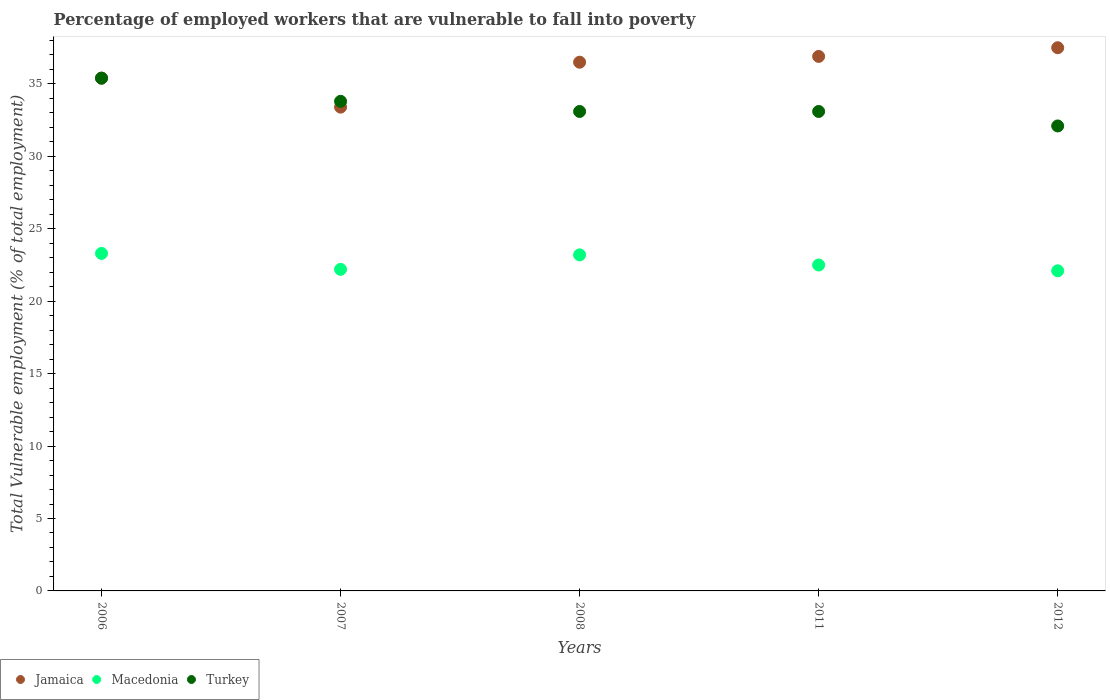What is the percentage of employed workers who are vulnerable to fall into poverty in Turkey in 2006?
Offer a very short reply. 35.4. Across all years, what is the maximum percentage of employed workers who are vulnerable to fall into poverty in Jamaica?
Your answer should be compact. 37.5. Across all years, what is the minimum percentage of employed workers who are vulnerable to fall into poverty in Jamaica?
Offer a very short reply. 33.4. In which year was the percentage of employed workers who are vulnerable to fall into poverty in Turkey maximum?
Make the answer very short. 2006. What is the total percentage of employed workers who are vulnerable to fall into poverty in Macedonia in the graph?
Your response must be concise. 113.3. What is the difference between the percentage of employed workers who are vulnerable to fall into poverty in Jamaica in 2008 and the percentage of employed workers who are vulnerable to fall into poverty in Turkey in 2007?
Provide a short and direct response. 2.7. What is the average percentage of employed workers who are vulnerable to fall into poverty in Macedonia per year?
Your response must be concise. 22.66. In the year 2006, what is the difference between the percentage of employed workers who are vulnerable to fall into poverty in Macedonia and percentage of employed workers who are vulnerable to fall into poverty in Turkey?
Provide a short and direct response. -12.1. In how many years, is the percentage of employed workers who are vulnerable to fall into poverty in Turkey greater than 8 %?
Your answer should be very brief. 5. What is the ratio of the percentage of employed workers who are vulnerable to fall into poverty in Turkey in 2006 to that in 2008?
Offer a very short reply. 1.07. Is the difference between the percentage of employed workers who are vulnerable to fall into poverty in Macedonia in 2006 and 2007 greater than the difference between the percentage of employed workers who are vulnerable to fall into poverty in Turkey in 2006 and 2007?
Provide a short and direct response. No. What is the difference between the highest and the second highest percentage of employed workers who are vulnerable to fall into poverty in Jamaica?
Ensure brevity in your answer.  0.6. What is the difference between the highest and the lowest percentage of employed workers who are vulnerable to fall into poverty in Macedonia?
Provide a succinct answer. 1.2. Is the sum of the percentage of employed workers who are vulnerable to fall into poverty in Turkey in 2008 and 2011 greater than the maximum percentage of employed workers who are vulnerable to fall into poverty in Jamaica across all years?
Your answer should be compact. Yes. Is it the case that in every year, the sum of the percentage of employed workers who are vulnerable to fall into poverty in Turkey and percentage of employed workers who are vulnerable to fall into poverty in Macedonia  is greater than the percentage of employed workers who are vulnerable to fall into poverty in Jamaica?
Your answer should be compact. Yes. How many dotlines are there?
Offer a terse response. 3. Are the values on the major ticks of Y-axis written in scientific E-notation?
Provide a succinct answer. No. Where does the legend appear in the graph?
Make the answer very short. Bottom left. How many legend labels are there?
Offer a very short reply. 3. How are the legend labels stacked?
Keep it short and to the point. Horizontal. What is the title of the graph?
Ensure brevity in your answer.  Percentage of employed workers that are vulnerable to fall into poverty. Does "Chile" appear as one of the legend labels in the graph?
Give a very brief answer. No. What is the label or title of the Y-axis?
Offer a very short reply. Total Vulnerable employment (% of total employment). What is the Total Vulnerable employment (% of total employment) in Jamaica in 2006?
Your response must be concise. 35.4. What is the Total Vulnerable employment (% of total employment) in Macedonia in 2006?
Keep it short and to the point. 23.3. What is the Total Vulnerable employment (% of total employment) of Turkey in 2006?
Your response must be concise. 35.4. What is the Total Vulnerable employment (% of total employment) in Jamaica in 2007?
Give a very brief answer. 33.4. What is the Total Vulnerable employment (% of total employment) of Macedonia in 2007?
Your answer should be very brief. 22.2. What is the Total Vulnerable employment (% of total employment) of Turkey in 2007?
Offer a terse response. 33.8. What is the Total Vulnerable employment (% of total employment) in Jamaica in 2008?
Your answer should be very brief. 36.5. What is the Total Vulnerable employment (% of total employment) of Macedonia in 2008?
Offer a very short reply. 23.2. What is the Total Vulnerable employment (% of total employment) of Turkey in 2008?
Your answer should be compact. 33.1. What is the Total Vulnerable employment (% of total employment) in Jamaica in 2011?
Offer a very short reply. 36.9. What is the Total Vulnerable employment (% of total employment) of Macedonia in 2011?
Provide a succinct answer. 22.5. What is the Total Vulnerable employment (% of total employment) of Turkey in 2011?
Keep it short and to the point. 33.1. What is the Total Vulnerable employment (% of total employment) of Jamaica in 2012?
Make the answer very short. 37.5. What is the Total Vulnerable employment (% of total employment) in Macedonia in 2012?
Give a very brief answer. 22.1. What is the Total Vulnerable employment (% of total employment) in Turkey in 2012?
Provide a succinct answer. 32.1. Across all years, what is the maximum Total Vulnerable employment (% of total employment) in Jamaica?
Provide a short and direct response. 37.5. Across all years, what is the maximum Total Vulnerable employment (% of total employment) of Macedonia?
Your answer should be very brief. 23.3. Across all years, what is the maximum Total Vulnerable employment (% of total employment) in Turkey?
Offer a very short reply. 35.4. Across all years, what is the minimum Total Vulnerable employment (% of total employment) of Jamaica?
Offer a terse response. 33.4. Across all years, what is the minimum Total Vulnerable employment (% of total employment) of Macedonia?
Ensure brevity in your answer.  22.1. Across all years, what is the minimum Total Vulnerable employment (% of total employment) in Turkey?
Your response must be concise. 32.1. What is the total Total Vulnerable employment (% of total employment) of Jamaica in the graph?
Provide a short and direct response. 179.7. What is the total Total Vulnerable employment (% of total employment) in Macedonia in the graph?
Provide a short and direct response. 113.3. What is the total Total Vulnerable employment (% of total employment) in Turkey in the graph?
Provide a succinct answer. 167.5. What is the difference between the Total Vulnerable employment (% of total employment) of Turkey in 2006 and that in 2007?
Your answer should be compact. 1.6. What is the difference between the Total Vulnerable employment (% of total employment) in Turkey in 2006 and that in 2008?
Offer a terse response. 2.3. What is the difference between the Total Vulnerable employment (% of total employment) of Macedonia in 2006 and that in 2011?
Keep it short and to the point. 0.8. What is the difference between the Total Vulnerable employment (% of total employment) of Macedonia in 2006 and that in 2012?
Give a very brief answer. 1.2. What is the difference between the Total Vulnerable employment (% of total employment) of Turkey in 2006 and that in 2012?
Provide a short and direct response. 3.3. What is the difference between the Total Vulnerable employment (% of total employment) in Macedonia in 2007 and that in 2008?
Make the answer very short. -1. What is the difference between the Total Vulnerable employment (% of total employment) in Turkey in 2007 and that in 2008?
Your answer should be very brief. 0.7. What is the difference between the Total Vulnerable employment (% of total employment) in Macedonia in 2007 and that in 2011?
Your answer should be very brief. -0.3. What is the difference between the Total Vulnerable employment (% of total employment) of Turkey in 2007 and that in 2012?
Provide a succinct answer. 1.7. What is the difference between the Total Vulnerable employment (% of total employment) in Macedonia in 2008 and that in 2011?
Your answer should be very brief. 0.7. What is the difference between the Total Vulnerable employment (% of total employment) in Turkey in 2008 and that in 2011?
Offer a very short reply. 0. What is the difference between the Total Vulnerable employment (% of total employment) of Macedonia in 2008 and that in 2012?
Your response must be concise. 1.1. What is the difference between the Total Vulnerable employment (% of total employment) of Jamaica in 2006 and the Total Vulnerable employment (% of total employment) of Turkey in 2008?
Provide a succinct answer. 2.3. What is the difference between the Total Vulnerable employment (% of total employment) in Macedonia in 2006 and the Total Vulnerable employment (% of total employment) in Turkey in 2008?
Provide a succinct answer. -9.8. What is the difference between the Total Vulnerable employment (% of total employment) in Jamaica in 2006 and the Total Vulnerable employment (% of total employment) in Macedonia in 2011?
Ensure brevity in your answer.  12.9. What is the difference between the Total Vulnerable employment (% of total employment) of Jamaica in 2006 and the Total Vulnerable employment (% of total employment) of Turkey in 2012?
Provide a short and direct response. 3.3. What is the difference between the Total Vulnerable employment (% of total employment) of Macedonia in 2006 and the Total Vulnerable employment (% of total employment) of Turkey in 2012?
Offer a very short reply. -8.8. What is the difference between the Total Vulnerable employment (% of total employment) of Jamaica in 2007 and the Total Vulnerable employment (% of total employment) of Turkey in 2008?
Offer a terse response. 0.3. What is the difference between the Total Vulnerable employment (% of total employment) of Jamaica in 2007 and the Total Vulnerable employment (% of total employment) of Turkey in 2011?
Provide a succinct answer. 0.3. What is the difference between the Total Vulnerable employment (% of total employment) in Macedonia in 2007 and the Total Vulnerable employment (% of total employment) in Turkey in 2011?
Your answer should be very brief. -10.9. What is the difference between the Total Vulnerable employment (% of total employment) in Jamaica in 2007 and the Total Vulnerable employment (% of total employment) in Macedonia in 2012?
Provide a short and direct response. 11.3. What is the difference between the Total Vulnerable employment (% of total employment) in Jamaica in 2007 and the Total Vulnerable employment (% of total employment) in Turkey in 2012?
Offer a terse response. 1.3. What is the difference between the Total Vulnerable employment (% of total employment) of Jamaica in 2008 and the Total Vulnerable employment (% of total employment) of Macedonia in 2011?
Make the answer very short. 14. What is the difference between the Total Vulnerable employment (% of total employment) of Jamaica in 2008 and the Total Vulnerable employment (% of total employment) of Macedonia in 2012?
Provide a succinct answer. 14.4. What is the difference between the Total Vulnerable employment (% of total employment) of Jamaica in 2011 and the Total Vulnerable employment (% of total employment) of Macedonia in 2012?
Your answer should be very brief. 14.8. What is the difference between the Total Vulnerable employment (% of total employment) of Macedonia in 2011 and the Total Vulnerable employment (% of total employment) of Turkey in 2012?
Your response must be concise. -9.6. What is the average Total Vulnerable employment (% of total employment) in Jamaica per year?
Provide a succinct answer. 35.94. What is the average Total Vulnerable employment (% of total employment) in Macedonia per year?
Provide a succinct answer. 22.66. What is the average Total Vulnerable employment (% of total employment) of Turkey per year?
Offer a terse response. 33.5. In the year 2007, what is the difference between the Total Vulnerable employment (% of total employment) of Jamaica and Total Vulnerable employment (% of total employment) of Macedonia?
Your answer should be compact. 11.2. In the year 2007, what is the difference between the Total Vulnerable employment (% of total employment) in Jamaica and Total Vulnerable employment (% of total employment) in Turkey?
Your answer should be compact. -0.4. In the year 2008, what is the difference between the Total Vulnerable employment (% of total employment) of Jamaica and Total Vulnerable employment (% of total employment) of Macedonia?
Ensure brevity in your answer.  13.3. In the year 2008, what is the difference between the Total Vulnerable employment (% of total employment) in Jamaica and Total Vulnerable employment (% of total employment) in Turkey?
Your answer should be very brief. 3.4. In the year 2011, what is the difference between the Total Vulnerable employment (% of total employment) in Jamaica and Total Vulnerable employment (% of total employment) in Turkey?
Ensure brevity in your answer.  3.8. In the year 2011, what is the difference between the Total Vulnerable employment (% of total employment) of Macedonia and Total Vulnerable employment (% of total employment) of Turkey?
Your answer should be compact. -10.6. In the year 2012, what is the difference between the Total Vulnerable employment (% of total employment) of Jamaica and Total Vulnerable employment (% of total employment) of Macedonia?
Ensure brevity in your answer.  15.4. In the year 2012, what is the difference between the Total Vulnerable employment (% of total employment) of Jamaica and Total Vulnerable employment (% of total employment) of Turkey?
Make the answer very short. 5.4. In the year 2012, what is the difference between the Total Vulnerable employment (% of total employment) in Macedonia and Total Vulnerable employment (% of total employment) in Turkey?
Give a very brief answer. -10. What is the ratio of the Total Vulnerable employment (% of total employment) in Jamaica in 2006 to that in 2007?
Offer a terse response. 1.06. What is the ratio of the Total Vulnerable employment (% of total employment) in Macedonia in 2006 to that in 2007?
Keep it short and to the point. 1.05. What is the ratio of the Total Vulnerable employment (% of total employment) of Turkey in 2006 to that in 2007?
Provide a short and direct response. 1.05. What is the ratio of the Total Vulnerable employment (% of total employment) of Jamaica in 2006 to that in 2008?
Your answer should be very brief. 0.97. What is the ratio of the Total Vulnerable employment (% of total employment) in Macedonia in 2006 to that in 2008?
Your answer should be compact. 1. What is the ratio of the Total Vulnerable employment (% of total employment) of Turkey in 2006 to that in 2008?
Make the answer very short. 1.07. What is the ratio of the Total Vulnerable employment (% of total employment) of Jamaica in 2006 to that in 2011?
Provide a succinct answer. 0.96. What is the ratio of the Total Vulnerable employment (% of total employment) in Macedonia in 2006 to that in 2011?
Keep it short and to the point. 1.04. What is the ratio of the Total Vulnerable employment (% of total employment) of Turkey in 2006 to that in 2011?
Your answer should be very brief. 1.07. What is the ratio of the Total Vulnerable employment (% of total employment) of Jamaica in 2006 to that in 2012?
Offer a very short reply. 0.94. What is the ratio of the Total Vulnerable employment (% of total employment) in Macedonia in 2006 to that in 2012?
Offer a very short reply. 1.05. What is the ratio of the Total Vulnerable employment (% of total employment) of Turkey in 2006 to that in 2012?
Offer a terse response. 1.1. What is the ratio of the Total Vulnerable employment (% of total employment) of Jamaica in 2007 to that in 2008?
Your response must be concise. 0.92. What is the ratio of the Total Vulnerable employment (% of total employment) of Macedonia in 2007 to that in 2008?
Ensure brevity in your answer.  0.96. What is the ratio of the Total Vulnerable employment (% of total employment) in Turkey in 2007 to that in 2008?
Your answer should be very brief. 1.02. What is the ratio of the Total Vulnerable employment (% of total employment) in Jamaica in 2007 to that in 2011?
Offer a terse response. 0.91. What is the ratio of the Total Vulnerable employment (% of total employment) of Macedonia in 2007 to that in 2011?
Offer a terse response. 0.99. What is the ratio of the Total Vulnerable employment (% of total employment) of Turkey in 2007 to that in 2011?
Ensure brevity in your answer.  1.02. What is the ratio of the Total Vulnerable employment (% of total employment) of Jamaica in 2007 to that in 2012?
Your answer should be very brief. 0.89. What is the ratio of the Total Vulnerable employment (% of total employment) in Turkey in 2007 to that in 2012?
Give a very brief answer. 1.05. What is the ratio of the Total Vulnerable employment (% of total employment) of Jamaica in 2008 to that in 2011?
Offer a very short reply. 0.99. What is the ratio of the Total Vulnerable employment (% of total employment) in Macedonia in 2008 to that in 2011?
Ensure brevity in your answer.  1.03. What is the ratio of the Total Vulnerable employment (% of total employment) of Jamaica in 2008 to that in 2012?
Your response must be concise. 0.97. What is the ratio of the Total Vulnerable employment (% of total employment) in Macedonia in 2008 to that in 2012?
Provide a short and direct response. 1.05. What is the ratio of the Total Vulnerable employment (% of total employment) in Turkey in 2008 to that in 2012?
Ensure brevity in your answer.  1.03. What is the ratio of the Total Vulnerable employment (% of total employment) of Macedonia in 2011 to that in 2012?
Provide a short and direct response. 1.02. What is the ratio of the Total Vulnerable employment (% of total employment) of Turkey in 2011 to that in 2012?
Your answer should be compact. 1.03. What is the difference between the highest and the second highest Total Vulnerable employment (% of total employment) in Jamaica?
Ensure brevity in your answer.  0.6. What is the difference between the highest and the second highest Total Vulnerable employment (% of total employment) of Turkey?
Your response must be concise. 1.6. What is the difference between the highest and the lowest Total Vulnerable employment (% of total employment) of Macedonia?
Your response must be concise. 1.2. What is the difference between the highest and the lowest Total Vulnerable employment (% of total employment) of Turkey?
Your answer should be very brief. 3.3. 